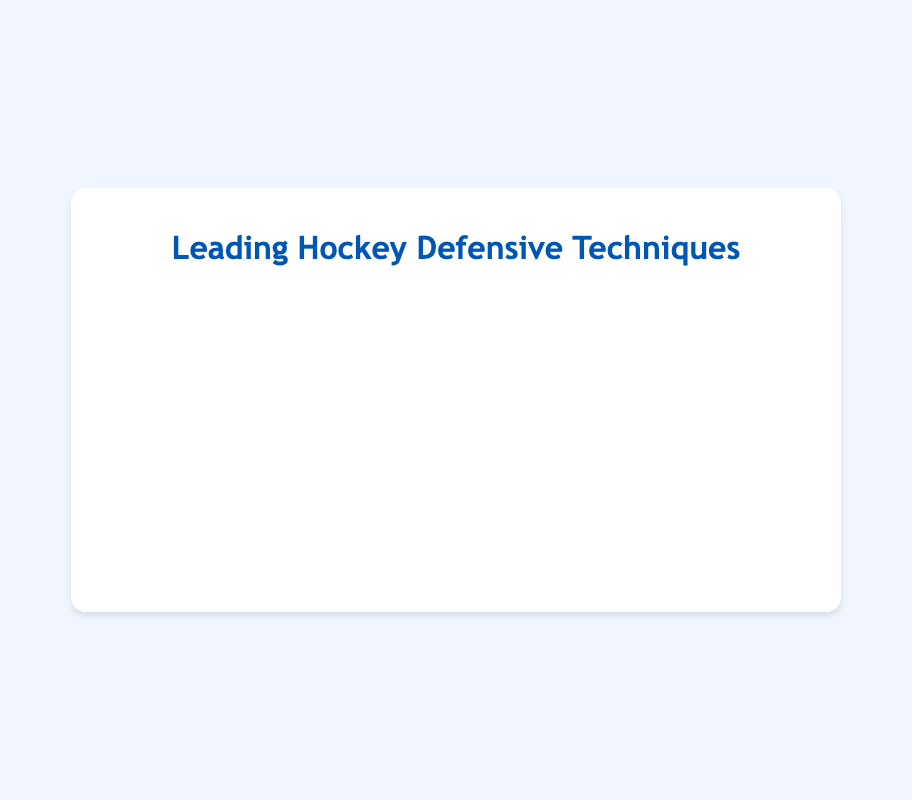Which technique is practiced the most per week? The longest bar represents the highest value. The bar for "Skating Backwards (Duncan Keith)" is the longest, indicating 9 hours per week.
Answer: Skating Backwards (Duncan Keith) Which technique is practiced the least per week? The shortest bar represents the lowest value. The bar for "Net Front Presence (Ryan McDonagh)" is the shortest, indicating 4 hours per week.
Answer: Net Front Presence (Ryan McDonagh) How many total hours per week do the players practice all techniques combined? Sum the hours for each technique: 9 + 8 + 7 + 7 + 6 + 6 + 6 + 5 + 5 + 4 = 63.
Answer: 63 What is the average hours per week spent practicing the techniques? Sum the hours and divide by the number of techniques: (9 + 8 + 7 + 7 + 6 + 6 + 6 + 5 + 5 + 4)/10 = 6.3.
Answer: 6.3 Is "Stick Positioning (Drew Doughty)" practiced more or less than "Poke Checking (Victor Hedman)"? Compare the values of both techniques. Both "Stick Positioning (Drew Doughty)" and "Poke Checking (Victor Hedman)" are 6 hours per week.
Answer: Equal What is the difference in hours per week between the most practiced technique and the least practiced technique? Subtract the hours for the least practiced from the most practiced: 9 (Skating Backwards) - 4 (Net Front Presence) = 5.
Answer: 5 Which techniques are practiced 6 hours per week? Identify bars with a value of 6 hours. "Stick Positioning (Drew Doughty)", "Poke Checking (Victor Hedman)", and "Puck Retrievals (Morgan Rielly)" are all practiced 6 hours per week.
Answer: Stick Positioning, Poke Checking, Puck Retrievals What color represents "Body Checking (Shea Weber)"? Observe the color of the bar next to the label "Body Checking (Shea Weber)". The bar is blue.
Answer: Blue 